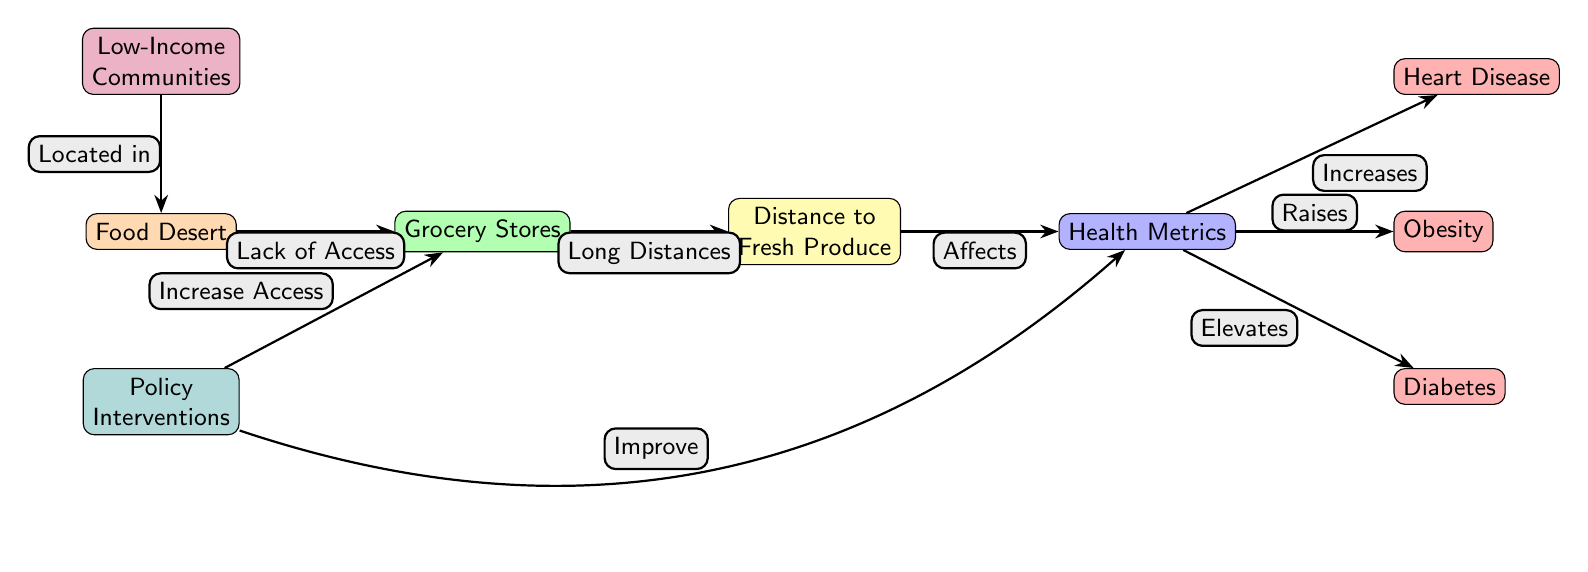What is the first node in the diagram? The first node is labeled as "Food Desert," indicating it is the starting point of the food chain.
Answer: Food Desert How many health metrics nodes are present? There are three health metrics nodes in the diagram: Heart Disease, Obesity, and Diabetes.
Answer: 3 What does "Grocery Stores" connect to? "Grocery Stores" connects to "Distance to Fresh Produce," showing that grocery stores are related to the availability of fresh produce.
Answer: Distance to Fresh Produce Which community type is linked to the "Food Desert"? "Low-Income Communities" is connected to the "Food Desert," indicating that they are often located within food deserts.
Answer: Low-Income Communities What is the effect of policy interventions on grocery stores? The policy interventions are intended to "Increase Access" to grocery stores, highlighting a solution to the lack of access.
Answer: Increase Access What relationships exist between health metrics and health issues? Health metrics are linked to three health issues: "Increases" or "Raises" Heart Disease, "Raises" Obesity, and "Elevates" Diabetes, showing the negative impacts of health metrics.
Answer: Increases, Raises, Elevates How do policy interventions affect health metrics? Policy interventions aim to "Improve" health metrics, suggesting that they have a positive impact on overall health outcomes.
Answer: Improve What is the relationship between distance to fresh produce and health metrics? The "Distance to Fresh Produce" is identified as affecting health metrics, indicating that greater distances may lead to poorer health outcomes.
Answer: Affects What type of arrows are used to indicate relationships in the diagram? The arrows are labeled, with descriptions such as "Lack of Access," "Long Distances," and various impacts related to health metrics, indicating the type of relationships between nodes.
Answer: Labeled arrows 